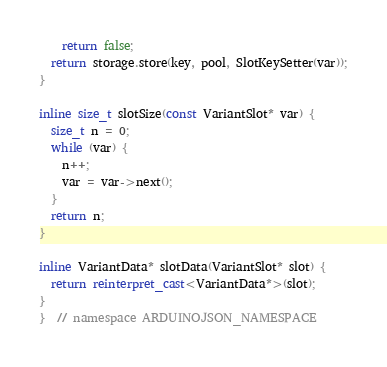<code> <loc_0><loc_0><loc_500><loc_500><_C++_>    return false;
  return storage.store(key, pool, SlotKeySetter(var));
}

inline size_t slotSize(const VariantSlot* var) {
  size_t n = 0;
  while (var) {
    n++;
    var = var->next();
  }
  return n;
}

inline VariantData* slotData(VariantSlot* slot) {
  return reinterpret_cast<VariantData*>(slot);
}
}  // namespace ARDUINOJSON_NAMESPACE
</code> 